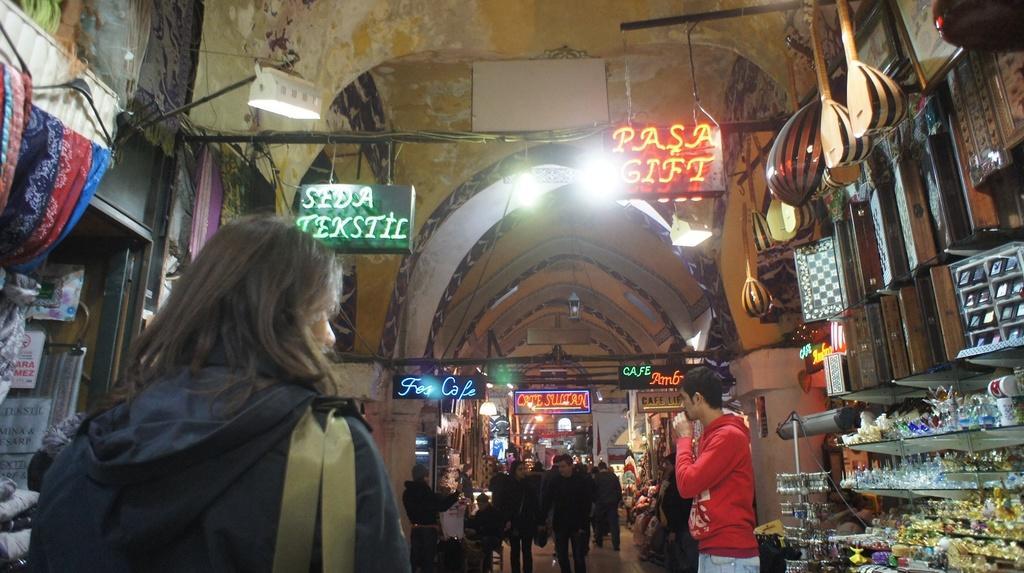In one or two sentences, can you explain what this image depicts? This image consists of persons standing and walking. In the center on the right side there are objects and there are boards with some text written on it. On the left side there are clothes hanging and there are lights and some boards with some text written on it. 